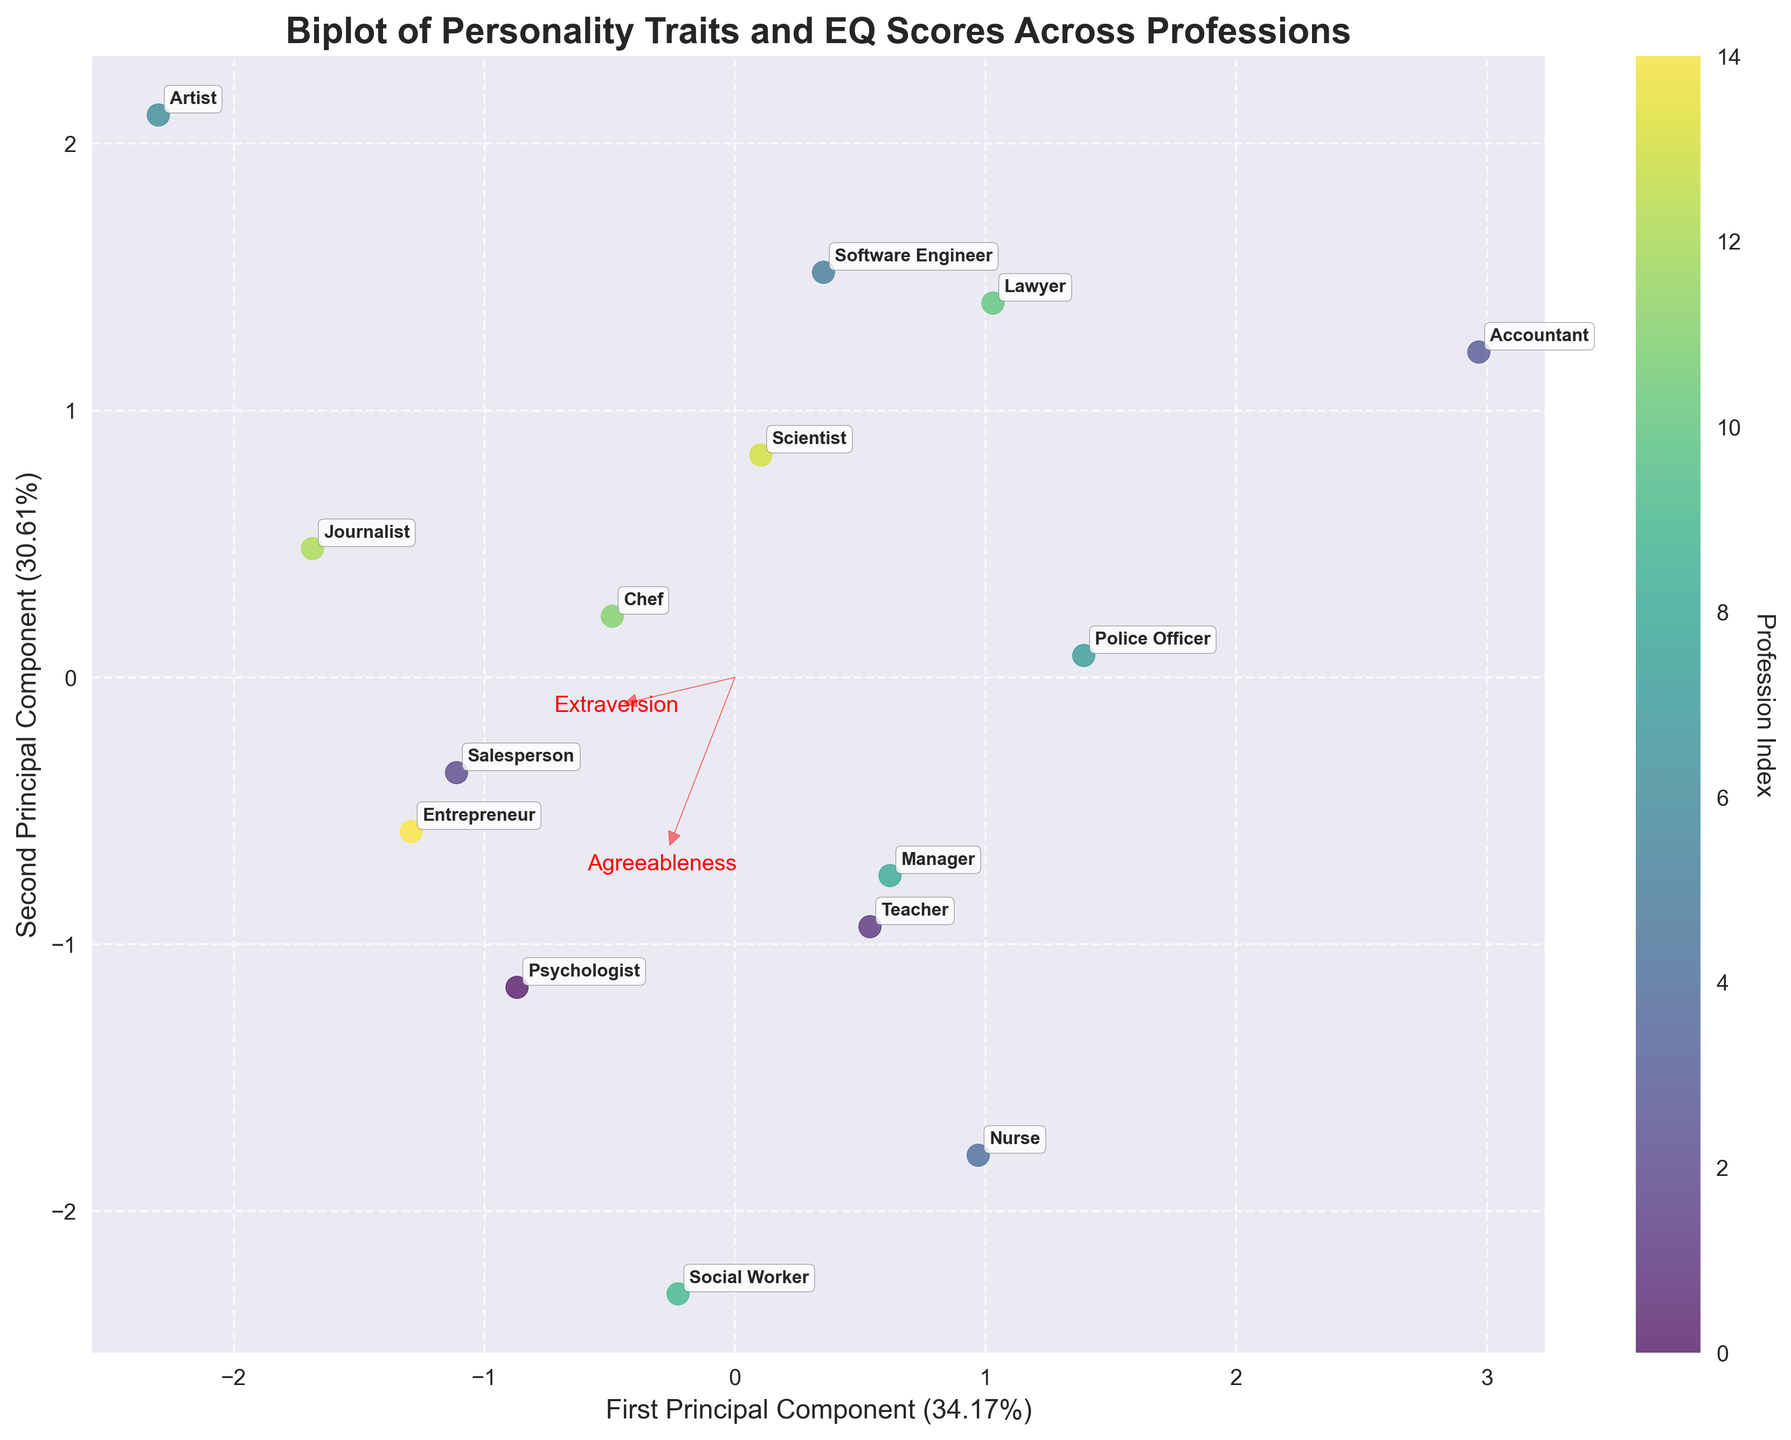what is the title of the plot? The title is displayed at the top of the plot, and it summarizes the content of the visual representation. It helps viewers to understand the focus of the analysis.
Answer: Biplot of Personality Traits and EQ Scores Across Professions How many professions are represented in the figure? By counting the data points and associated profession labels in the biplot, you can determine the number of distinct professions shown.
Answer: 15 Which profession has the highest EQ Score, and which plot axis direction does it primarily associate with? The EQ Score is highest for the profession where the data point is furthest in the direction of the respective arrows for the EQ Score dimension. Look for the corresponding label in that direction.
Answer: Social Worker, points towards high positive placement on the plot Which two features are the most positively correlated, and how can you tell? In a biplot, feature vectors that are close to each other indicate a high positive correlation. Identify two vectors that are closely aligned.
Answer: Agreeableness and Conscientiousness Which profession shows a balanced combination of high Neuroticism and high Openness? Look for the profession labels positioned near the vectors representing high Neuroticism and high Openness on the biplot to find the one balanced between these two traits.
Answer: Artist Among the vectors for the personality traits, which one has the smallest influence in distinguishing the professions on the biplot? The length of the vector indicates the influence; a shorter vector signifies lesser influence in distinguishing the data points.
Answer: Agreeableness Which profession is positioned closest to the center of the plot and what does this imply about its traits? The position closest to the origin (0,0) indicates that this profession has average scores across all personality traits relative to others. Identify the profession at this position.
Answer: Software Engineer, implying average traits Are Extraversion and Conscientiousness positively or negatively correlated, based on the plot? By observing the angle between the vectors for Extraversion and Conscientiousness, we determine the type of correlation. If the vectors point in the same general direction, they are positively correlated; otherwise, negatively.
Answer: Positively correlated 